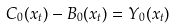<formula> <loc_0><loc_0><loc_500><loc_500>C _ { 0 } ( x _ { t } ) - B _ { 0 } ( x _ { t } ) = Y _ { 0 } ( x _ { t } )</formula> 